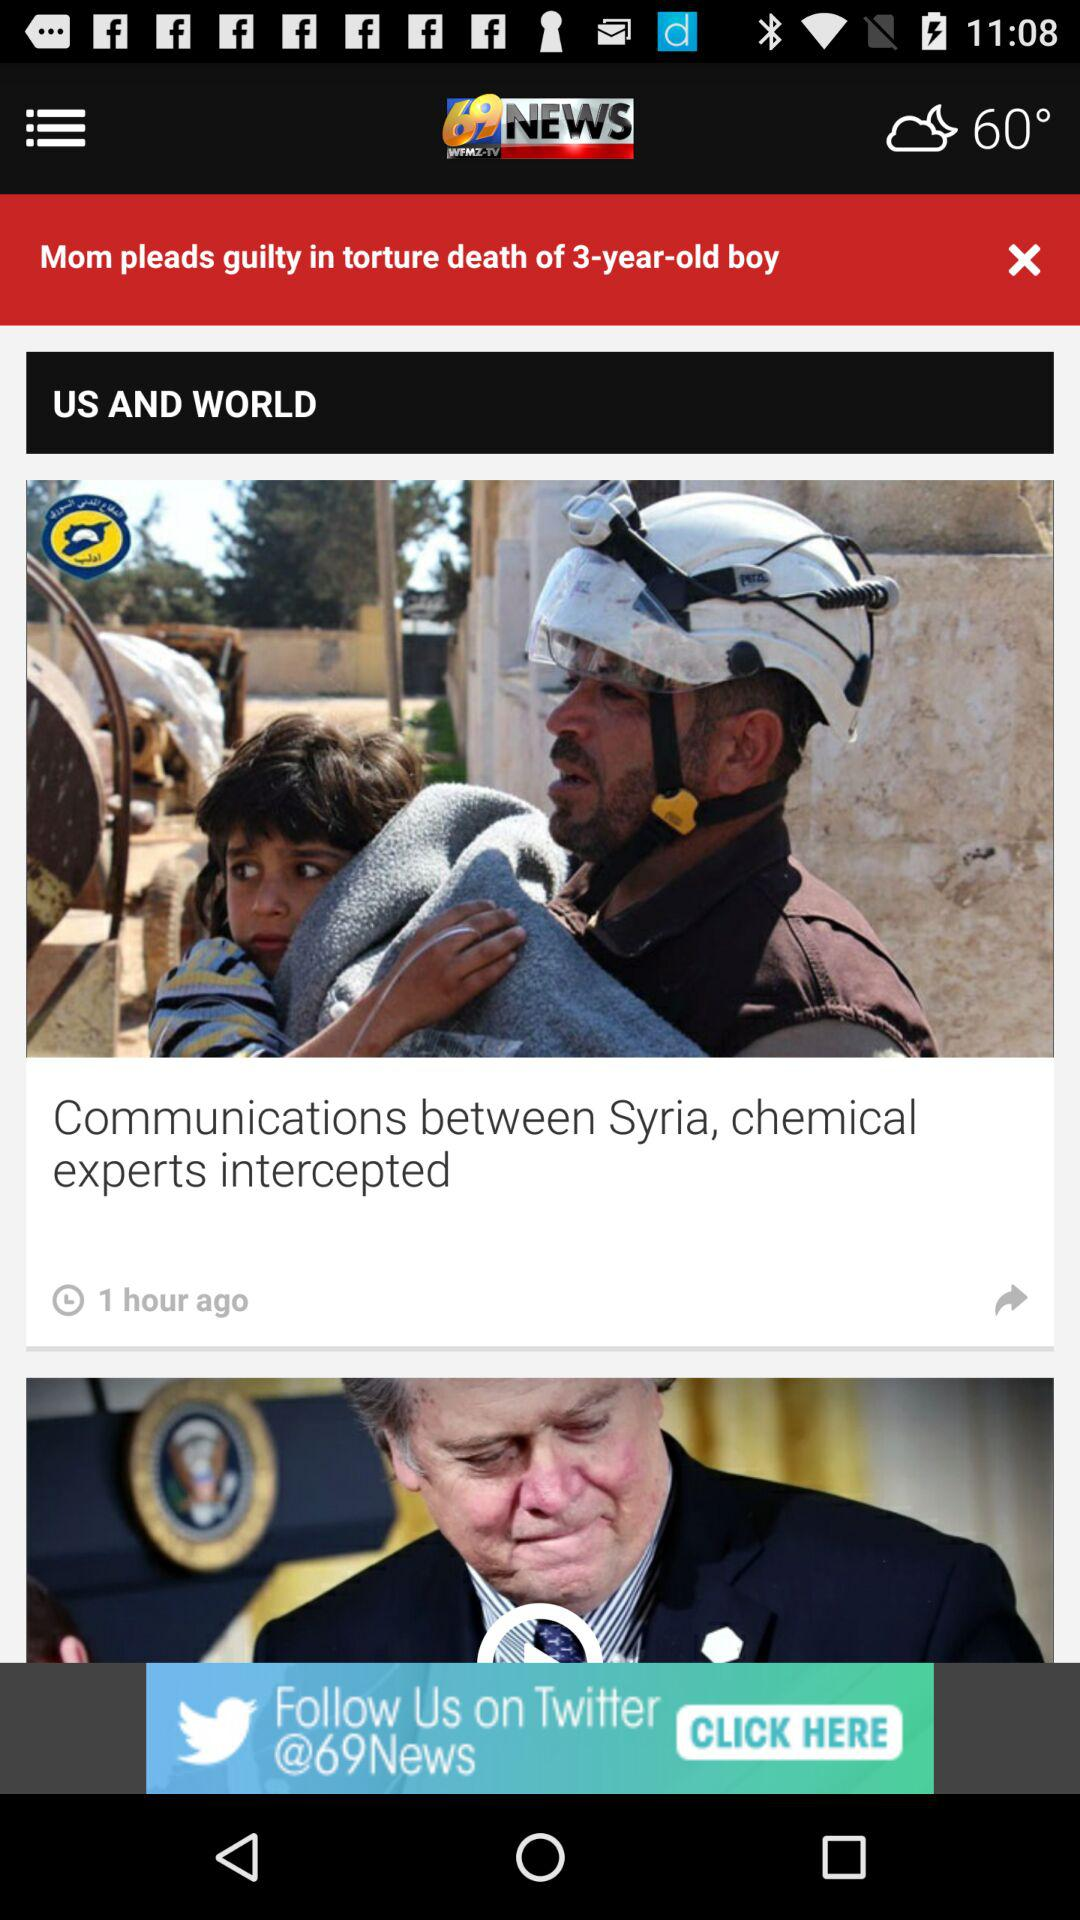What is the name of the application? The name of the application is "69 WFMZ-TV NEWS". 